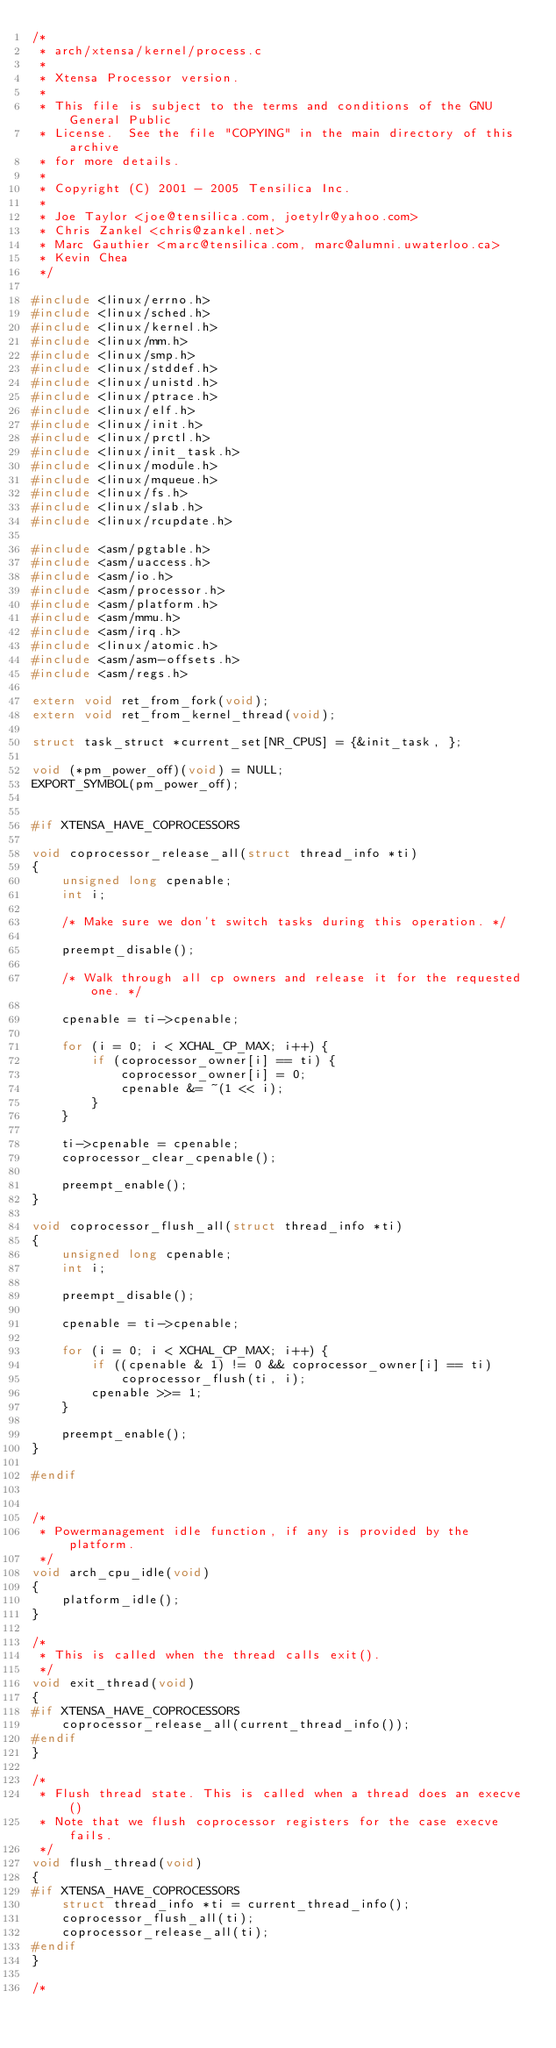Convert code to text. <code><loc_0><loc_0><loc_500><loc_500><_C_>/*
 * arch/xtensa/kernel/process.c
 *
 * Xtensa Processor version.
 *
 * This file is subject to the terms and conditions of the GNU General Public
 * License.  See the file "COPYING" in the main directory of this archive
 * for more details.
 *
 * Copyright (C) 2001 - 2005 Tensilica Inc.
 *
 * Joe Taylor <joe@tensilica.com, joetylr@yahoo.com>
 * Chris Zankel <chris@zankel.net>
 * Marc Gauthier <marc@tensilica.com, marc@alumni.uwaterloo.ca>
 * Kevin Chea
 */

#include <linux/errno.h>
#include <linux/sched.h>
#include <linux/kernel.h>
#include <linux/mm.h>
#include <linux/smp.h>
#include <linux/stddef.h>
#include <linux/unistd.h>
#include <linux/ptrace.h>
#include <linux/elf.h>
#include <linux/init.h>
#include <linux/prctl.h>
#include <linux/init_task.h>
#include <linux/module.h>
#include <linux/mqueue.h>
#include <linux/fs.h>
#include <linux/slab.h>
#include <linux/rcupdate.h>

#include <asm/pgtable.h>
#include <asm/uaccess.h>
#include <asm/io.h>
#include <asm/processor.h>
#include <asm/platform.h>
#include <asm/mmu.h>
#include <asm/irq.h>
#include <linux/atomic.h>
#include <asm/asm-offsets.h>
#include <asm/regs.h>

extern void ret_from_fork(void);
extern void ret_from_kernel_thread(void);

struct task_struct *current_set[NR_CPUS] = {&init_task, };

void (*pm_power_off)(void) = NULL;
EXPORT_SYMBOL(pm_power_off);


#if XTENSA_HAVE_COPROCESSORS

void coprocessor_release_all(struct thread_info *ti)
{
	unsigned long cpenable;
	int i;

	/* Make sure we don't switch tasks during this operation. */

	preempt_disable();

	/* Walk through all cp owners and release it for the requested one. */

	cpenable = ti->cpenable;

	for (i = 0; i < XCHAL_CP_MAX; i++) {
		if (coprocessor_owner[i] == ti) {
			coprocessor_owner[i] = 0;
			cpenable &= ~(1 << i);
		}
	}

	ti->cpenable = cpenable;
	coprocessor_clear_cpenable();

	preempt_enable();
}

void coprocessor_flush_all(struct thread_info *ti)
{
	unsigned long cpenable;
	int i;

	preempt_disable();

	cpenable = ti->cpenable;

	for (i = 0; i < XCHAL_CP_MAX; i++) {
		if ((cpenable & 1) != 0 && coprocessor_owner[i] == ti)
			coprocessor_flush(ti, i);
		cpenable >>= 1;
	}

	preempt_enable();
}

#endif


/*
 * Powermanagement idle function, if any is provided by the platform.
 */
void arch_cpu_idle(void)
{
	platform_idle();
}

/*
 * This is called when the thread calls exit().
 */
void exit_thread(void)
{
#if XTENSA_HAVE_COPROCESSORS
	coprocessor_release_all(current_thread_info());
#endif
}

/*
 * Flush thread state. This is called when a thread does an execve()
 * Note that we flush coprocessor registers for the case execve fails.
 */
void flush_thread(void)
{
#if XTENSA_HAVE_COPROCESSORS
	struct thread_info *ti = current_thread_info();
	coprocessor_flush_all(ti);
	coprocessor_release_all(ti);
#endif
}

/*</code> 